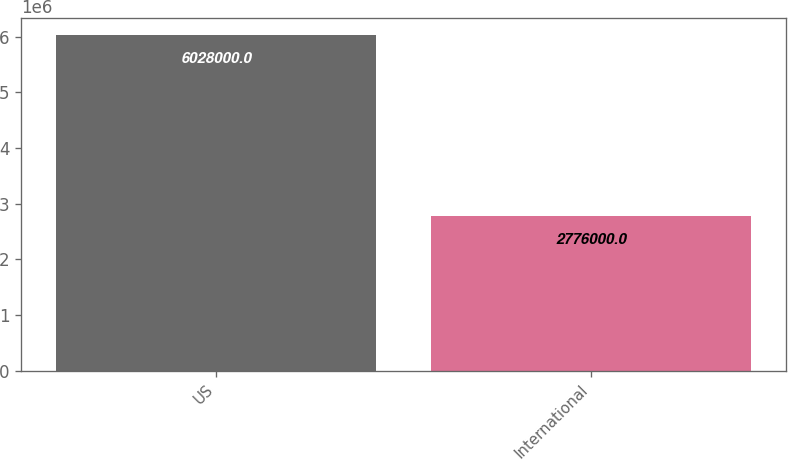Convert chart. <chart><loc_0><loc_0><loc_500><loc_500><bar_chart><fcel>US<fcel>International<nl><fcel>6.028e+06<fcel>2.776e+06<nl></chart> 